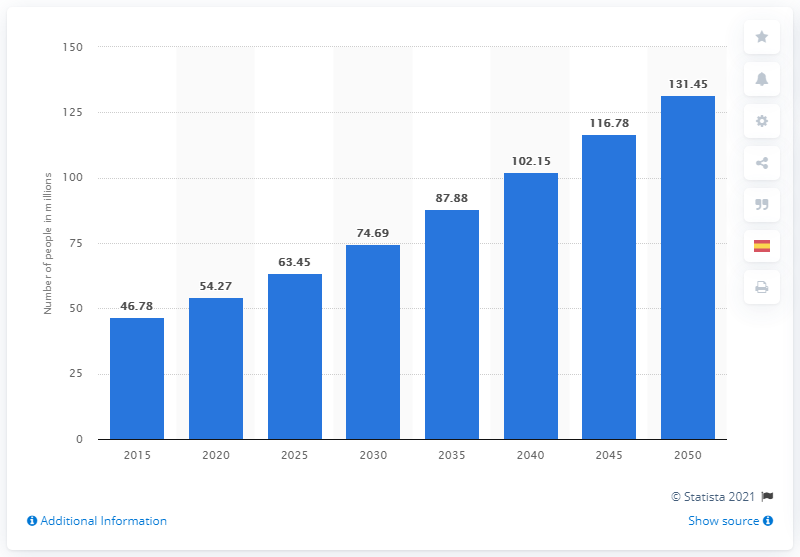Mention a couple of crucial points in this snapshot. The estimated value for the year 2015 is 46.78... 